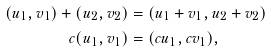<formula> <loc_0><loc_0><loc_500><loc_500>( u _ { 1 } , v _ { 1 } ) + ( u _ { 2 } , v _ { 2 } ) & = ( u _ { 1 } + v _ { 1 } , u _ { 2 } + v _ { 2 } ) \\ c ( u _ { 1 } , v _ { 1 } ) & = ( c u _ { 1 } , c v _ { 1 } ) ,</formula> 